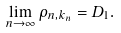Convert formula to latex. <formula><loc_0><loc_0><loc_500><loc_500>\lim _ { n \to \infty } \rho _ { n , k _ { n } } = D _ { 1 } .</formula> 